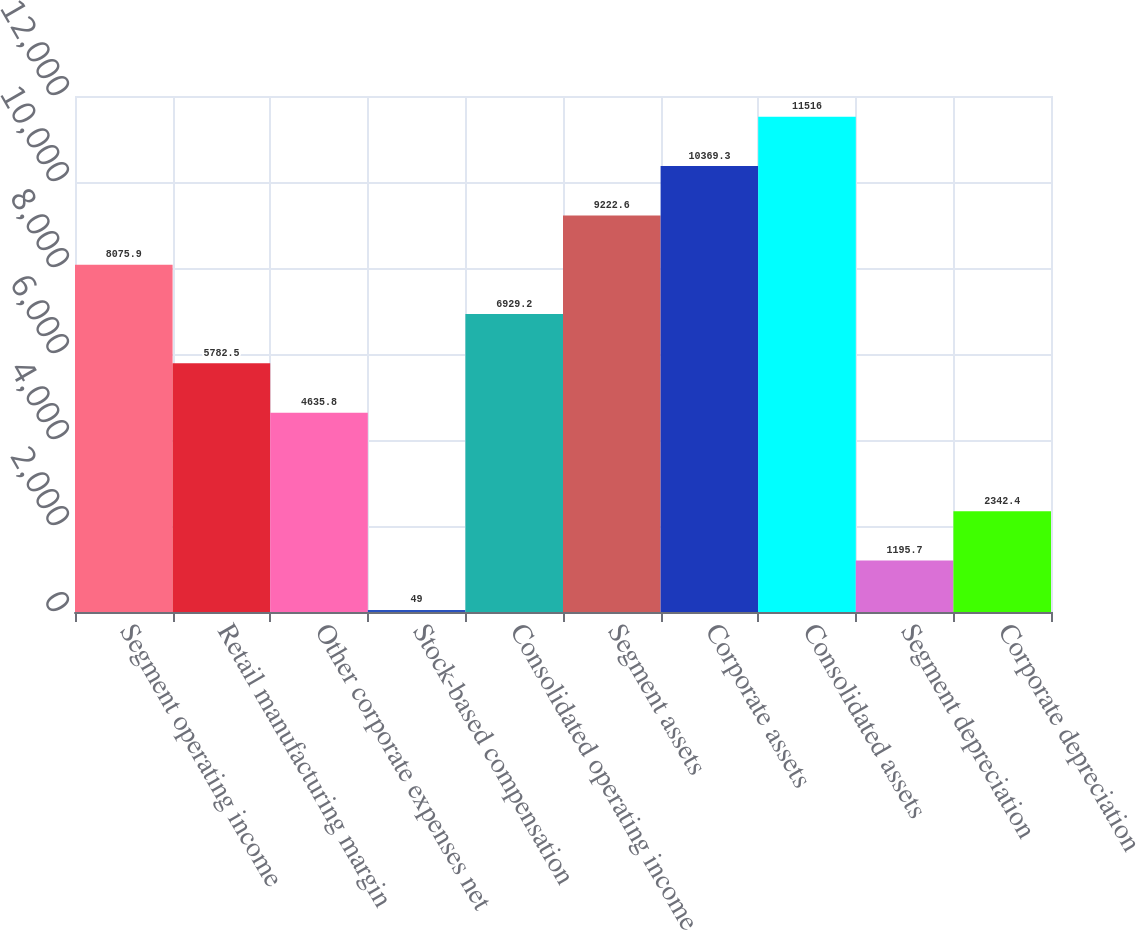Convert chart. <chart><loc_0><loc_0><loc_500><loc_500><bar_chart><fcel>Segment operating income<fcel>Retail manufacturing margin<fcel>Other corporate expenses net<fcel>Stock-based compensation<fcel>Consolidated operating income<fcel>Segment assets<fcel>Corporate assets<fcel>Consolidated assets<fcel>Segment depreciation<fcel>Corporate depreciation<nl><fcel>8075.9<fcel>5782.5<fcel>4635.8<fcel>49<fcel>6929.2<fcel>9222.6<fcel>10369.3<fcel>11516<fcel>1195.7<fcel>2342.4<nl></chart> 